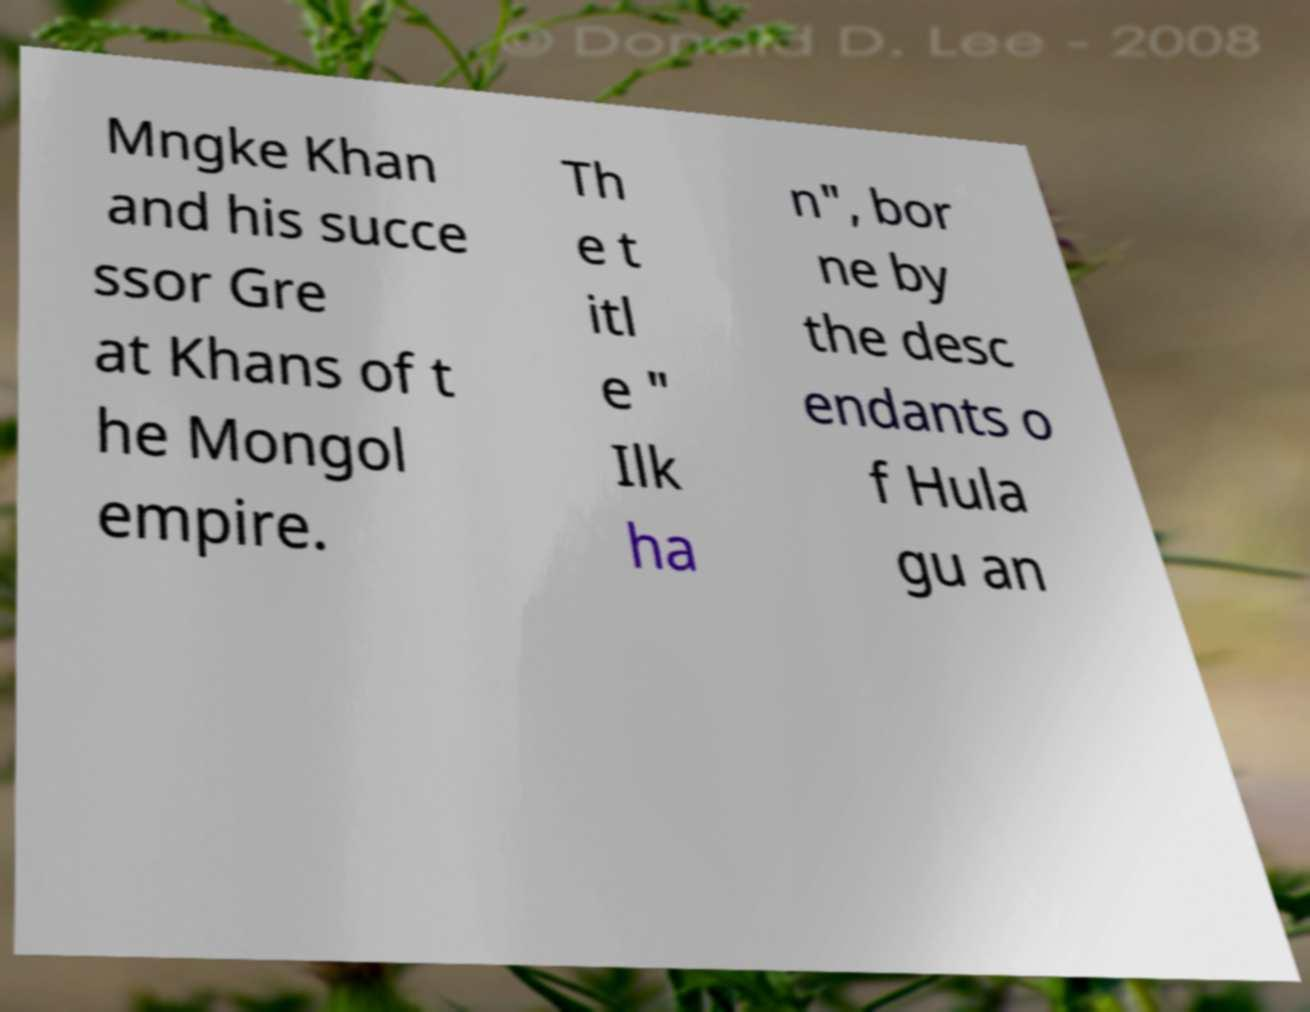Could you assist in decoding the text presented in this image and type it out clearly? Mngke Khan and his succe ssor Gre at Khans of t he Mongol empire. Th e t itl e " Ilk ha n", bor ne by the desc endants o f Hula gu an 